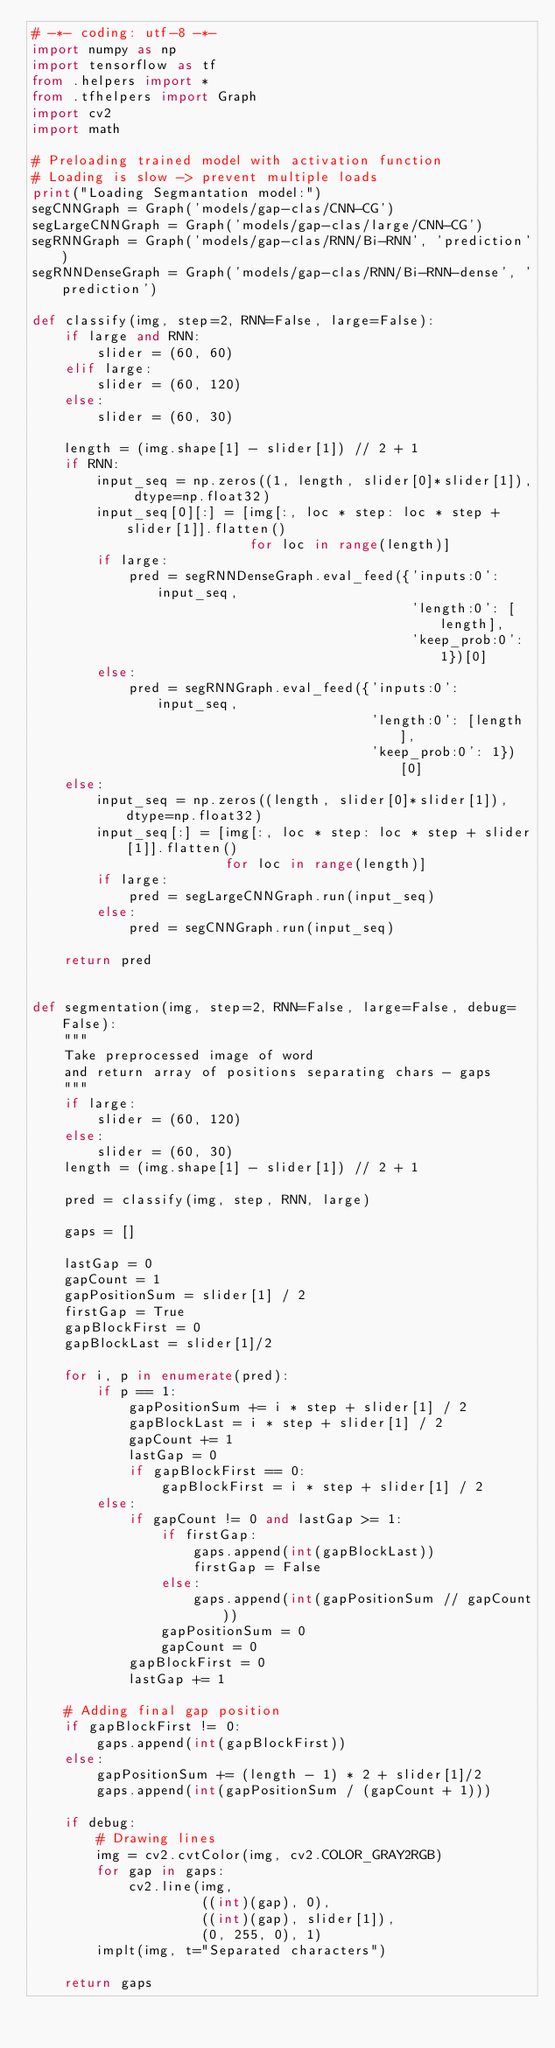Convert code to text. <code><loc_0><loc_0><loc_500><loc_500><_Python_># -*- coding: utf-8 -*-
import numpy as np
import tensorflow as tf
from .helpers import *
from .tfhelpers import Graph
import cv2
import math

# Preloading trained model with activation function
# Loading is slow -> prevent multiple loads
print("Loading Segmantation model:")
segCNNGraph = Graph('models/gap-clas/CNN-CG')
segLargeCNNGraph = Graph('models/gap-clas/large/CNN-CG')
segRNNGraph = Graph('models/gap-clas/RNN/Bi-RNN', 'prediction')
segRNNDenseGraph = Graph('models/gap-clas/RNN/Bi-RNN-dense', 'prediction')

def classify(img, step=2, RNN=False, large=False):
    if large and RNN:
        slider = (60, 60)
    elif large:
        slider = (60, 120)
    else:
        slider = (60, 30)
        
    length = (img.shape[1] - slider[1]) // 2 + 1
    if RNN:
        input_seq = np.zeros((1, length, slider[0]*slider[1]), dtype=np.float32)
        input_seq[0][:] = [img[:, loc * step: loc * step + slider[1]].flatten()
                           for loc in range(length)]
        if large:
            pred = segRNNDenseGraph.eval_feed({'inputs:0': input_seq,
                                               'length:0': [length],
                                               'keep_prob:0': 1})[0]
        else:
            pred = segRNNGraph.eval_feed({'inputs:0': input_seq,
                                          'length:0': [length],
                                          'keep_prob:0': 1})[0]
    else:
        input_seq = np.zeros((length, slider[0]*slider[1]), dtype=np.float32)
        input_seq[:] = [img[:, loc * step: loc * step + slider[1]].flatten()
                        for loc in range(length)]
        if large:
            pred = segLargeCNNGraph.run(input_seq)
        else:
            pred = segCNNGraph.run(input_seq)
        
    return pred
    

def segmentation(img, step=2, RNN=False, large=False, debug=False):
    """
    Take preprocessed image of word
    and return array of positions separating chars - gaps
    """        
    if large:
        slider = (60, 120)
    else:
        slider = (60, 30)
    length = (img.shape[1] - slider[1]) // 2 + 1
    
    pred = classify(img, step, RNN, large)

    gaps = []

    lastGap = 0
    gapCount = 1
    gapPositionSum = slider[1] / 2
    firstGap = True
    gapBlockFirst = 0
    gapBlockLast = slider[1]/2

    for i, p in enumerate(pred):
        if p == 1:
            gapPositionSum += i * step + slider[1] / 2
            gapBlockLast = i * step + slider[1] / 2
            gapCount += 1
            lastGap = 0
            if gapBlockFirst == 0:
                gapBlockFirst = i * step + slider[1] / 2
        else:
            if gapCount != 0 and lastGap >= 1:
                if firstGap:
                    gaps.append(int(gapBlockLast))
                    firstGap = False
                else:
                    gaps.append(int(gapPositionSum // gapCount))
                gapPositionSum = 0
                gapCount = 0
            gapBlockFirst = 0
            lastGap += 1

    # Adding final gap position
    if gapBlockFirst != 0:
        gaps.append(int(gapBlockFirst))
    else:
        gapPositionSum += (length - 1) * 2 + slider[1]/2
        gaps.append(int(gapPositionSum / (gapCount + 1)))
        
    if debug:
        # Drawing lines
        img = cv2.cvtColor(img, cv2.COLOR_GRAY2RGB)
        for gap in gaps:
            cv2.line(img,
                     ((int)(gap), 0),
                     ((int)(gap), slider[1]),
                     (0, 255, 0), 1)
        implt(img, t="Separated characters")
        
    return gaps</code> 